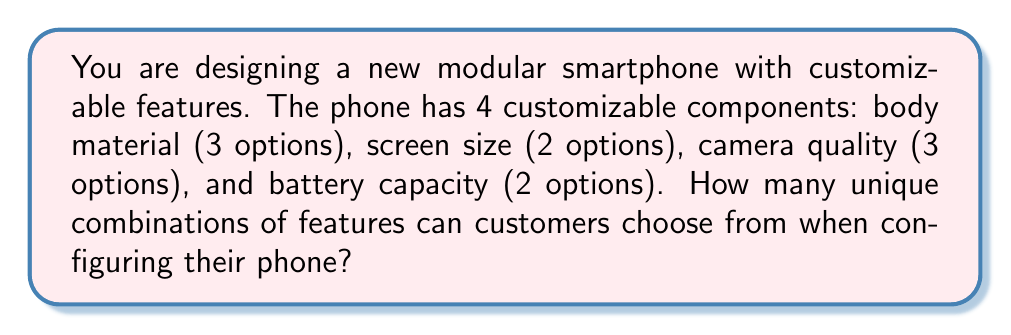Could you help me with this problem? To solve this problem, we'll use the multiplication principle of counting. This principle states that if we have several independent choices, the total number of possible outcomes is the product of the number of possibilities for each choice.

Let's break down the customizable components:

1. Body material: 3 options
2. Screen size: 2 options
3. Camera quality: 3 options
4. Battery capacity: 2 options

To find the total number of unique combinations, we multiply these numbers together:

$$ \text{Total combinations} = 3 \times 2 \times 3 \times 2 $$

Calculating this:

$$ \text{Total combinations} = 36 $$

Therefore, customers can choose from 36 unique combinations when configuring their modular smartphone.
Answer: 36 